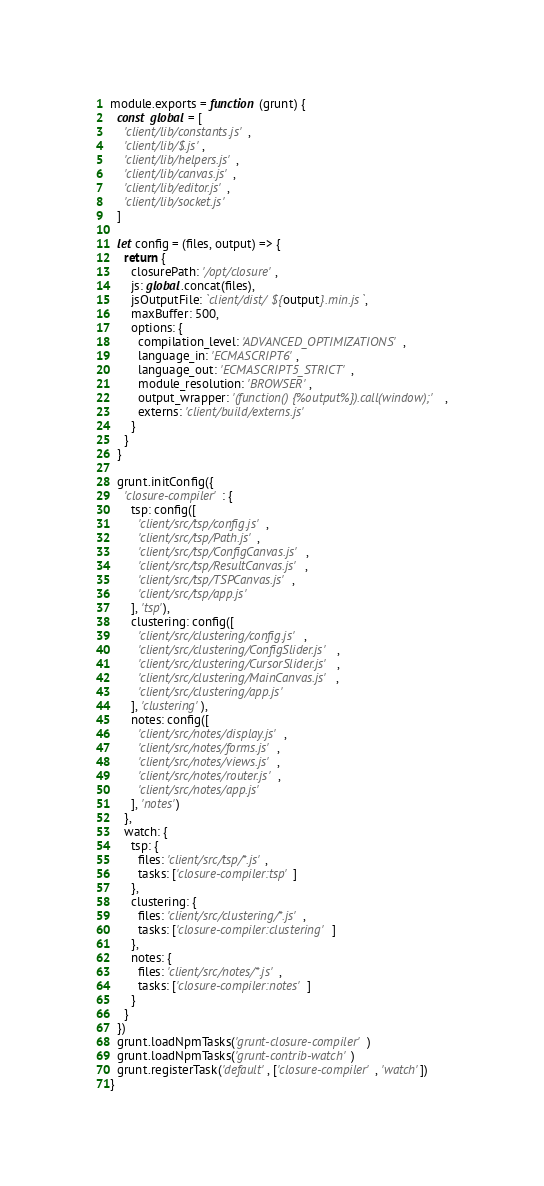<code> <loc_0><loc_0><loc_500><loc_500><_JavaScript_>module.exports = function (grunt) {
  const global = [
    'client/lib/constants.js',
    'client/lib/$.js',
    'client/lib/helpers.js',
    'client/lib/canvas.js',
    'client/lib/editor.js',
    'client/lib/socket.js'
  ]

  let config = (files, output) => {
    return {
      closurePath: '/opt/closure',
      js: global.concat(files),
      jsOutputFile: `client/dist/${output}.min.js`,
      maxBuffer: 500,
      options: {
        compilation_level: 'ADVANCED_OPTIMIZATIONS',
        language_in: 'ECMASCRIPT6',
        language_out: 'ECMASCRIPT5_STRICT',
        module_resolution: 'BROWSER',
        output_wrapper: '(function() {%output%}).call(window);',
        externs: 'client/build/externs.js'
      }
    }
  }

  grunt.initConfig({
    'closure-compiler': {
      tsp: config([
        'client/src/tsp/config.js',
        'client/src/tsp/Path.js',
        'client/src/tsp/ConfigCanvas.js',
        'client/src/tsp/ResultCanvas.js',
        'client/src/tsp/TSPCanvas.js',
        'client/src/tsp/app.js'
      ], 'tsp'),
      clustering: config([
        'client/src/clustering/config.js',
        'client/src/clustering/ConfigSlider.js',
        'client/src/clustering/CursorSlider.js',
        'client/src/clustering/MainCanvas.js',
        'client/src/clustering/app.js'
      ], 'clustering'),
      notes: config([
        'client/src/notes/display.js',
        'client/src/notes/forms.js',
        'client/src/notes/views.js',
        'client/src/notes/router.js',
        'client/src/notes/app.js'
      ], 'notes')
    },
    watch: {
      tsp: {
        files: 'client/src/tsp/*.js',
        tasks: ['closure-compiler:tsp']
      },
      clustering: {
        files: 'client/src/clustering/*.js',
        tasks: ['closure-compiler:clustering']
      },
      notes: {
        files: 'client/src/notes/*.js',
        tasks: ['closure-compiler:notes']
      }
    }
  })
  grunt.loadNpmTasks('grunt-closure-compiler')
  grunt.loadNpmTasks('grunt-contrib-watch')
  grunt.registerTask('default', ['closure-compiler', 'watch'])
}</code> 